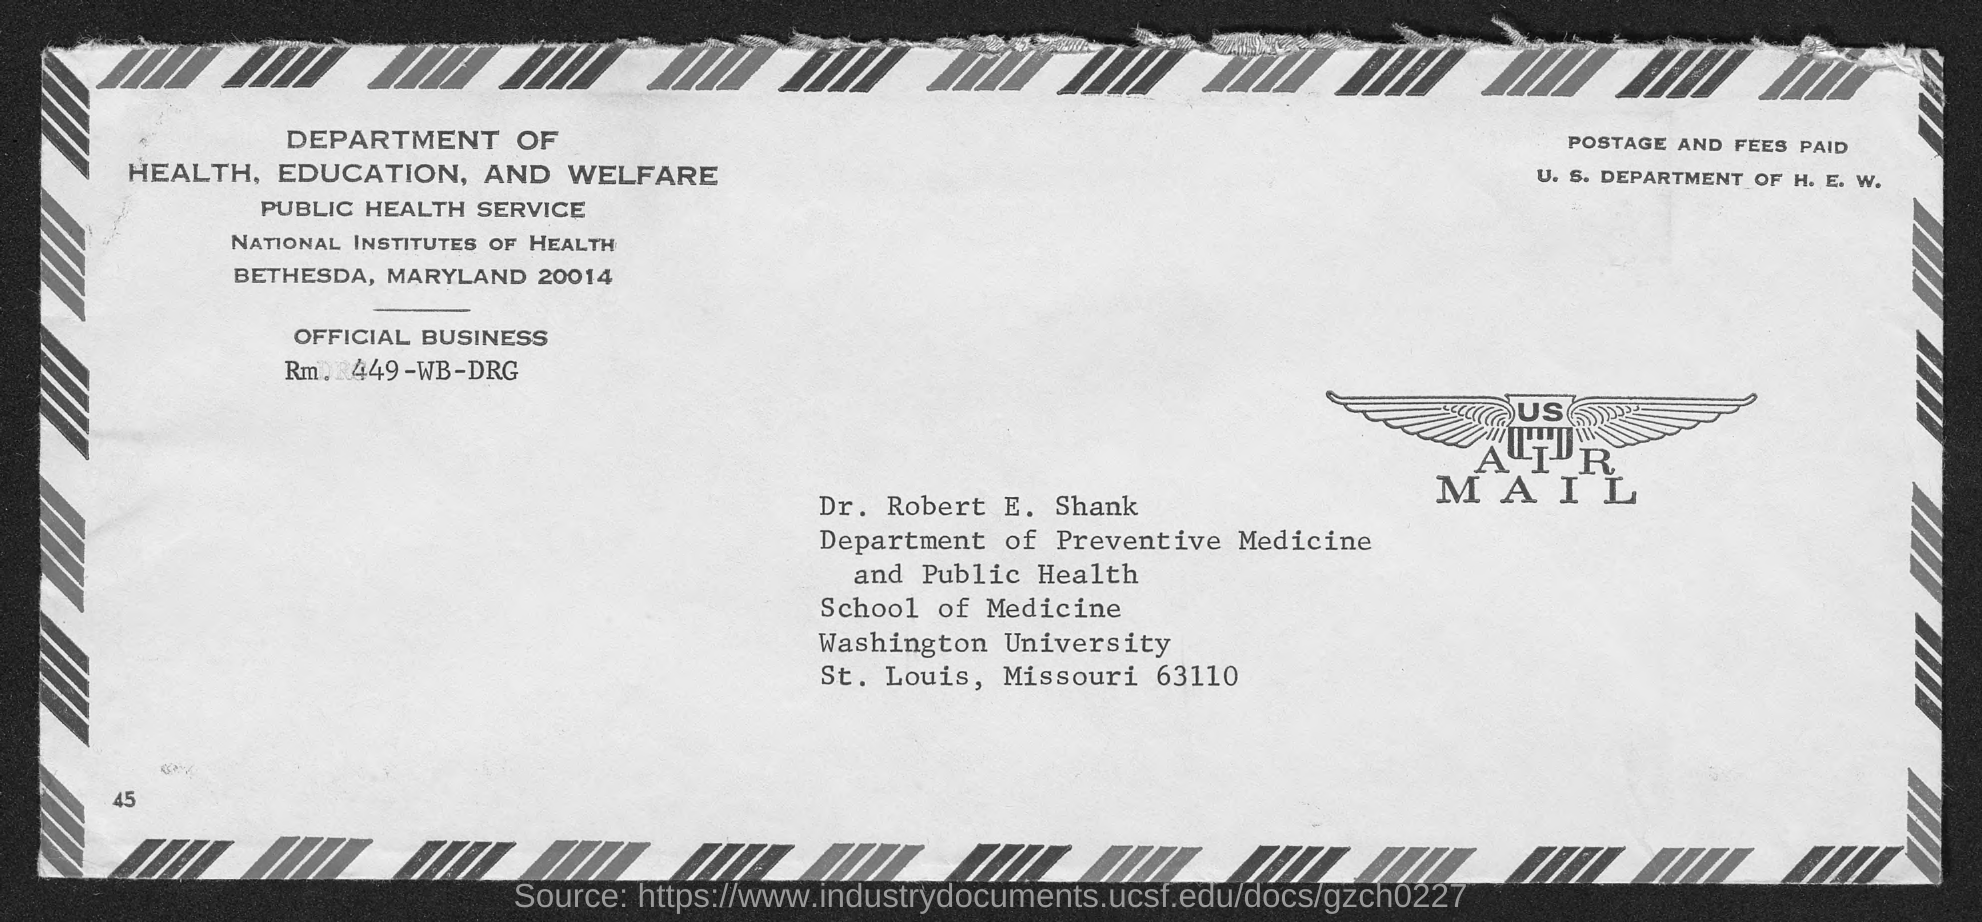Outline some significant characteristics in this image. Dr. Robert E. Shank belongs to the Department of Preventive Medicine and Public Health. Dr. Robert E. Shank is a resident of the state of Missouri. 